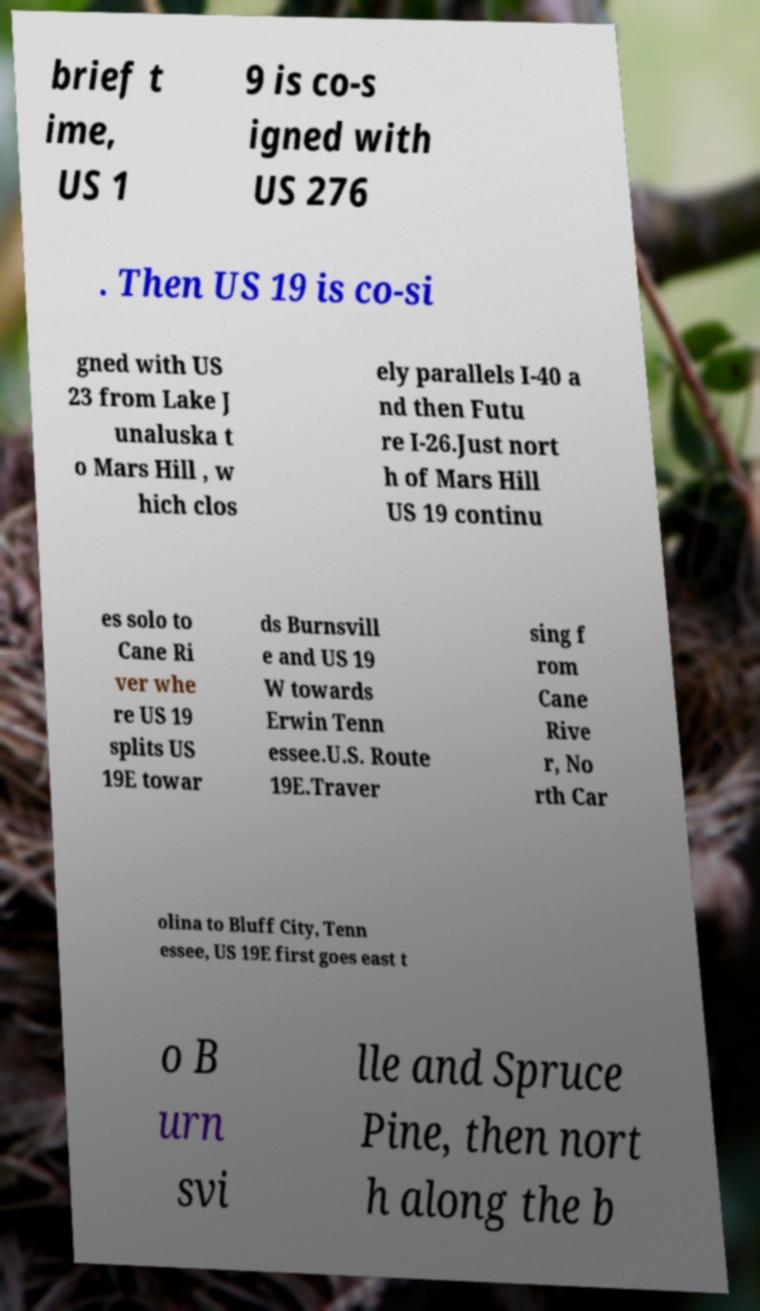Please read and relay the text visible in this image. What does it say? brief t ime, US 1 9 is co-s igned with US 276 . Then US 19 is co-si gned with US 23 from Lake J unaluska t o Mars Hill , w hich clos ely parallels I-40 a nd then Futu re I-26.Just nort h of Mars Hill US 19 continu es solo to Cane Ri ver whe re US 19 splits US 19E towar ds Burnsvill e and US 19 W towards Erwin Tenn essee.U.S. Route 19E.Traver sing f rom Cane Rive r, No rth Car olina to Bluff City, Tenn essee, US 19E first goes east t o B urn svi lle and Spruce Pine, then nort h along the b 